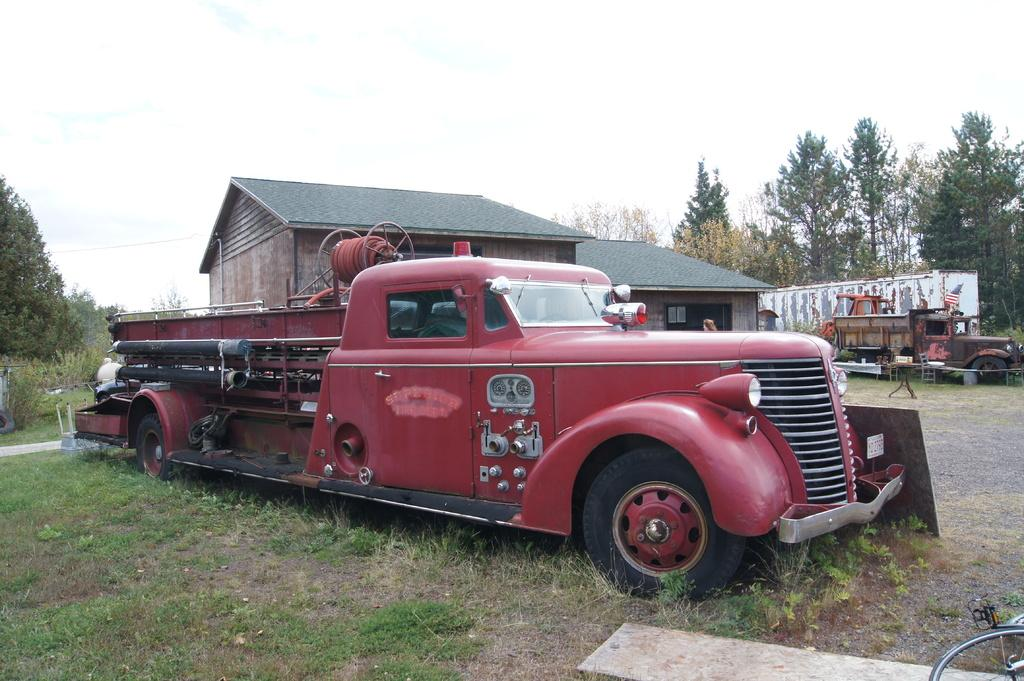What is the main subject in the image? There is a vehicle in the image. What can be seen behind the vehicle? There is a house behind the vehicle. Are there any other vehicles in the image? Yes, there are two damaged vehicles beside the house. What is the surrounding environment like? There are plenty of trees around the house. What type of silk is draped over the damaged vehicles? There is no silk present in the image; it only features a vehicle, a house, and two damaged vehicles. 